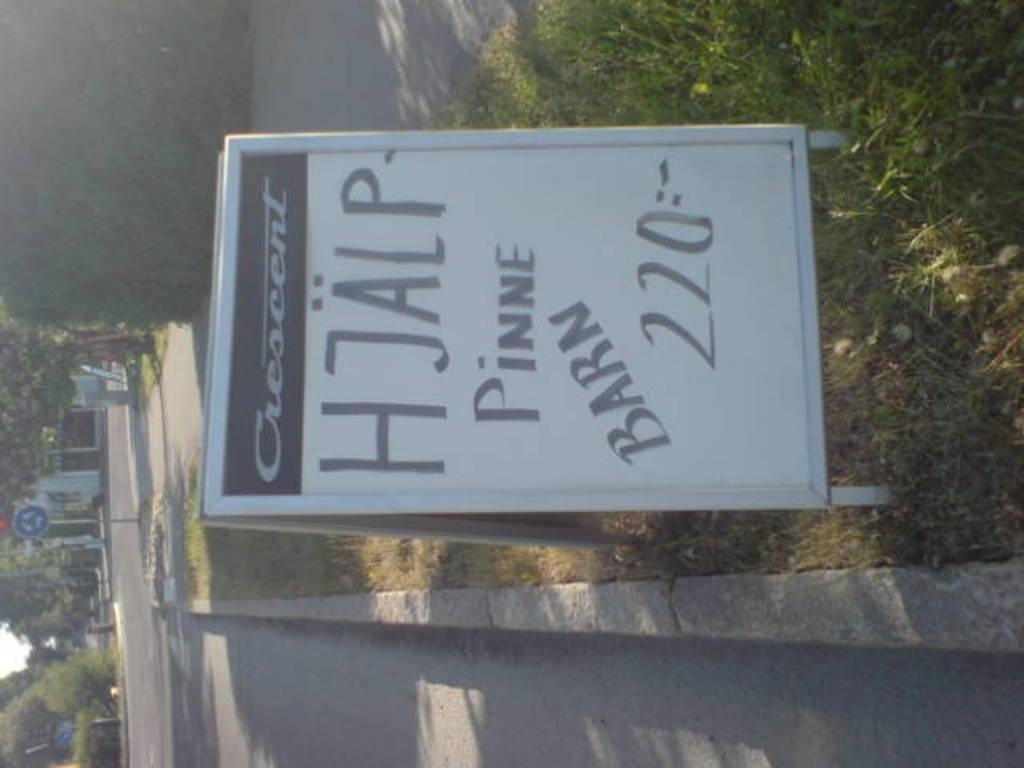What is the main object in the foreground of the image? There is a sign board in the image. What can be seen in the background of the image? There are trees, metal rods, and houses in the background of the image. How does the sand adjust its position in the image? There is no sand present in the image, so it cannot be adjusted or repositioned. 